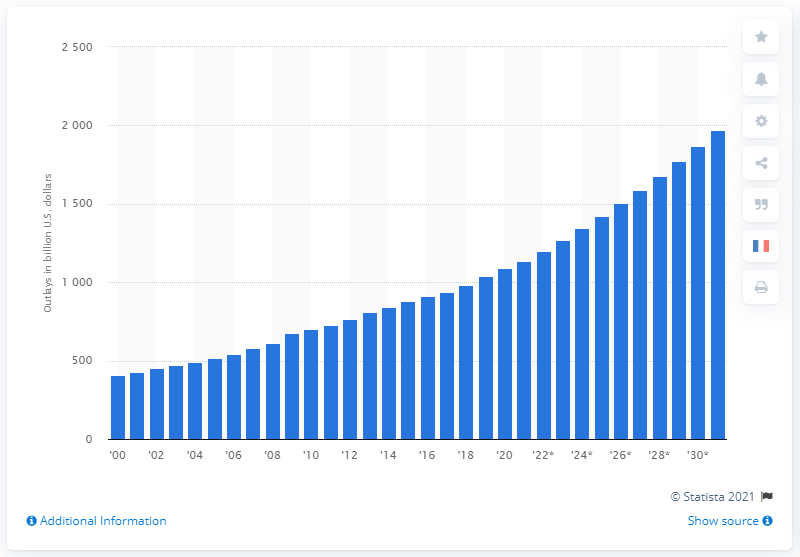Outline some significant characteristics in this image. The projected increase in social security outlays in the United States in 2031 is expected to be significant, as it is set to increase by 2071 in comparison to the year 1971. The total amount of social security outlays in the United States in 2020 was $1,090. 